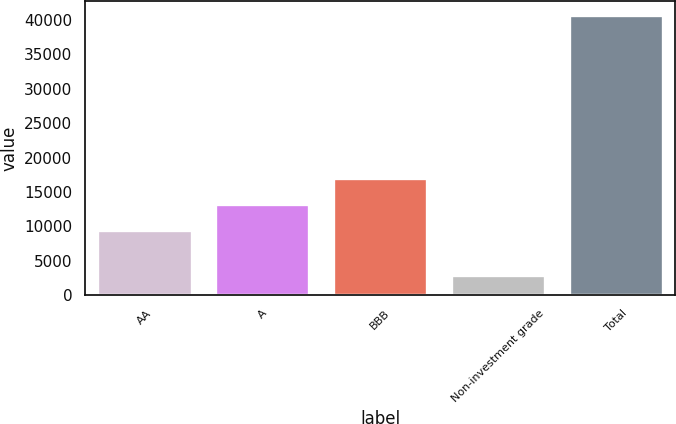Convert chart to OTSL. <chart><loc_0><loc_0><loc_500><loc_500><bar_chart><fcel>AA<fcel>A<fcel>BBB<fcel>Non-investment grade<fcel>Total<nl><fcel>9404<fcel>13186.3<fcel>16968.6<fcel>2945<fcel>40768<nl></chart> 